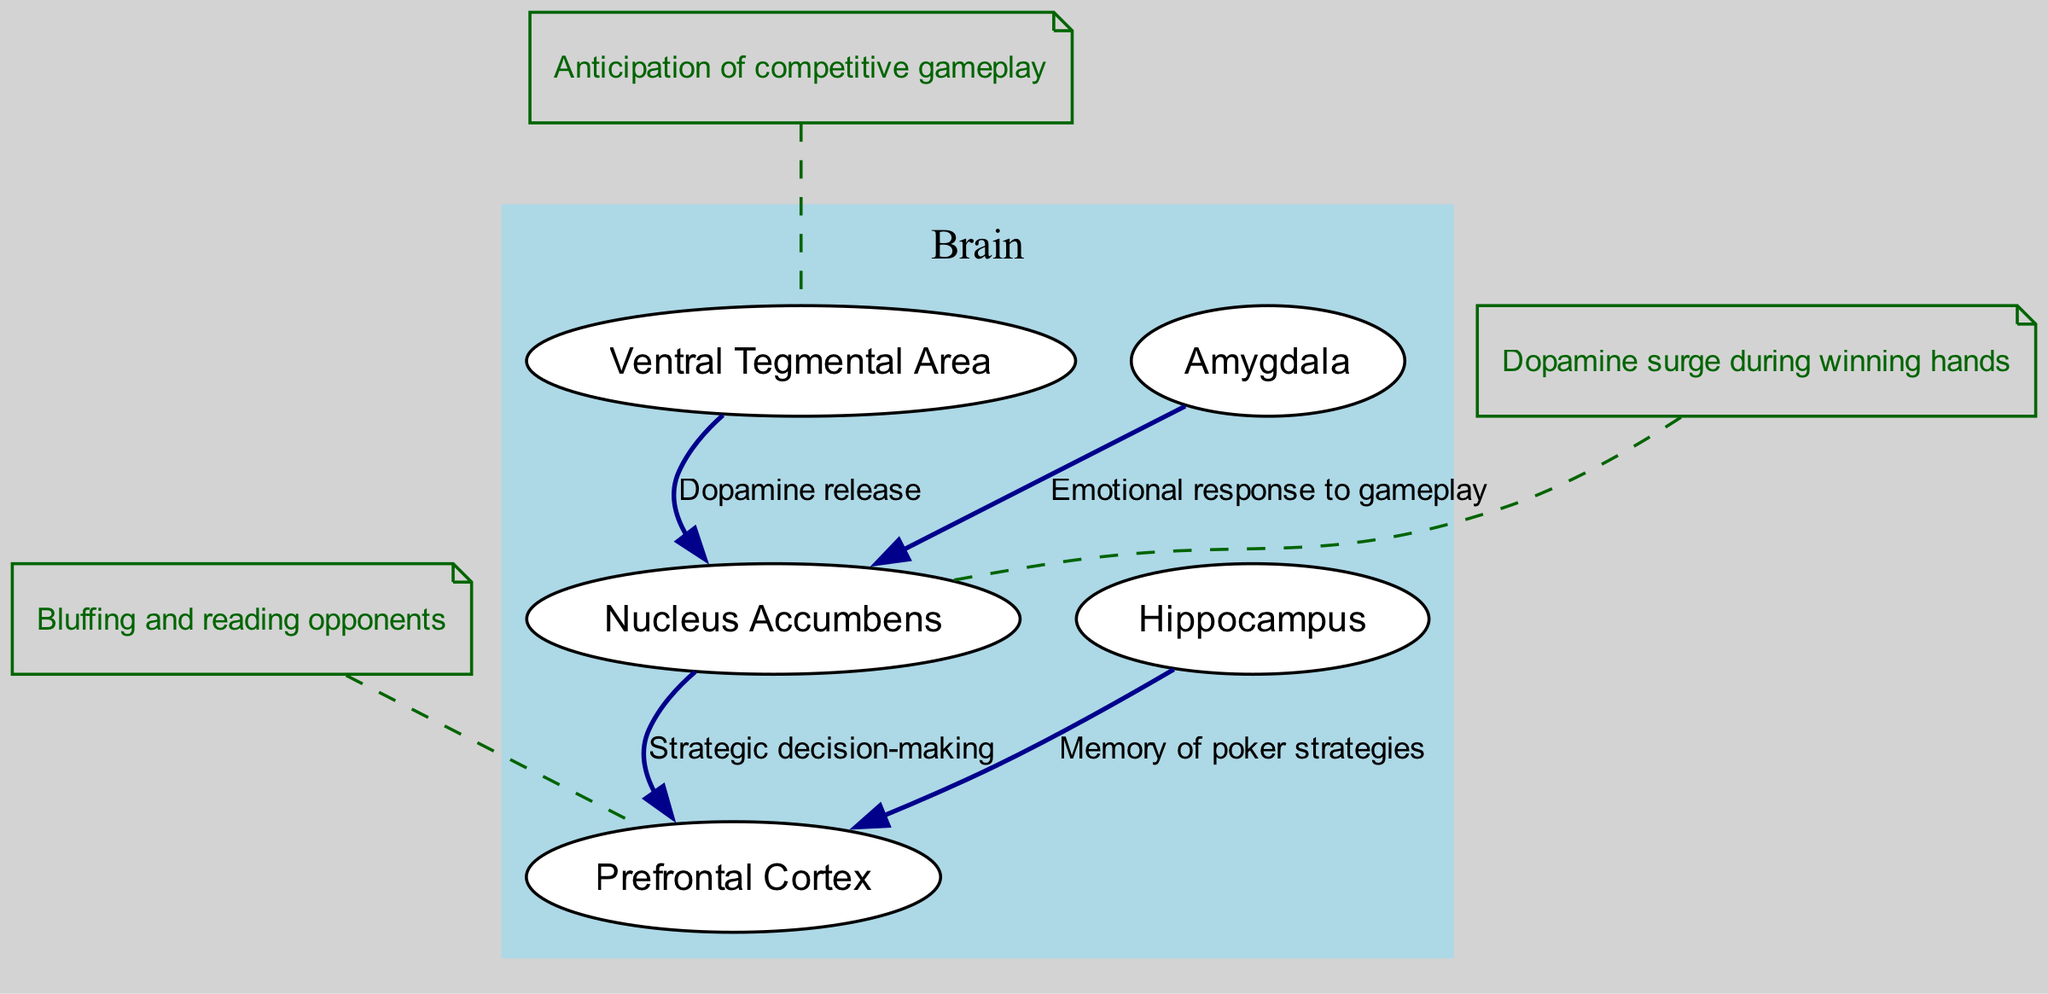What are the key reward centers in the brain highlighted in the diagram? The diagram features several key reward centers in the brain, including the Ventral Tegmental Area, Nucleus Accumbens, Prefrontal Cortex, Amygdala, and Hippocampus, all shown as nodes.
Answer: Ventral Tegmental Area, Nucleus Accumbens, Prefrontal Cortex, Amygdala, Hippocampus How many nodes are present in the diagram? The diagram includes a total of six nodes: the brain itself and five reward centers (VTA, NAcc, PFC, Amygdala, Hippocampus).
Answer: 6 Which center is primarily responsible for dopamine release? The diagram shows that the Ventral Tegmental Area is responsible for releasing dopamine, as indicated by the edge labeled "Dopamine release" connecting it to the Nucleus Accumbens.
Answer: Ventral Tegmental Area What role does the Nucleus Accumbens have in relation to the Prefrontal Cortex? The diagram indicates that the Nucleus Accumbens is linked to the Prefrontal Cortex with an edge labeled "Strategic decision-making", showing its role in influencing decision-making strategies during gameplay.
Answer: Strategic decision-making Which brain area is associated with emotional responses during gameplay? The diagram indicates that the Amygdala is involved in generating emotional responses to gameplay, as illustrated by the edge connecting it to the Nucleus Accumbens labeled "Emotional response to gameplay".
Answer: Amygdala How does the Hippocampus relate to memory in poker strategies? The diagram shows a connection from the Hippocampus to the Prefrontal Cortex labeled "Memory of poker strategies", highlighting how memory plays a role in decision-making processes during poker.
Answer: Memory of poker strategies What triggers the anticipation of competitive gameplay in the brain? According to the annotations in the diagram, the Ventral Tegmental Area triggers the anticipation of competitive gameplay.
Answer: Anticipation of competitive gameplay What type of responses does the Amygdala influence in competitive gameplay? The diagram notes that the Amygdala influences emotional responses during gameplay, suggesting its role in managing feelings such as excitement or anxiety.
Answer: Emotional responses What causes a dopamine surge in the Nucleus Accumbens? The annotation in the diagram states that a dopamine surge occurs during winning hands, indicating that successes in gameplay can trigger this response in the Nucleus Accumbens.
Answer: Winning hands 